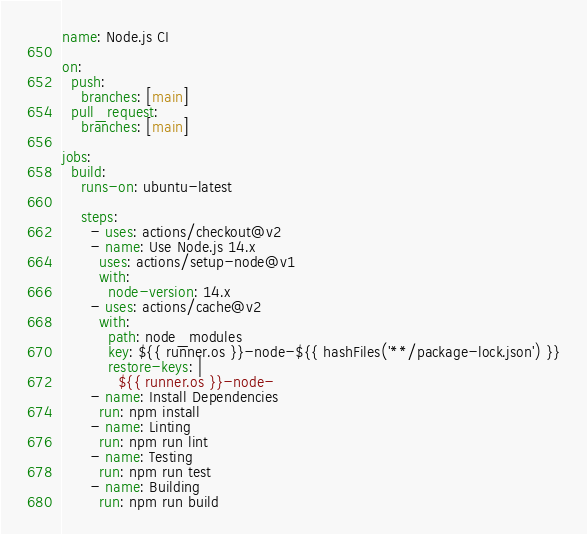Convert code to text. <code><loc_0><loc_0><loc_500><loc_500><_YAML_>name: Node.js CI

on:
  push:
    branches: [main]
  pull_request:
    branches: [main]

jobs:
  build:
    runs-on: ubuntu-latest

    steps:
      - uses: actions/checkout@v2
      - name: Use Node.js 14.x
        uses: actions/setup-node@v1
        with:
          node-version: 14.x
      - uses: actions/cache@v2
        with:
          path: node_modules
          key: ${{ runner.os }}-node-${{ hashFiles('**/package-lock.json') }}
          restore-keys: |
            ${{ runner.os }}-node-
      - name: Install Dependencies
        run: npm install
      - name: Linting
        run: npm run lint
      - name: Testing
        run: npm run test
      - name: Building
        run: npm run build</code> 